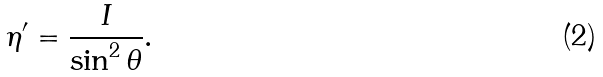<formula> <loc_0><loc_0><loc_500><loc_500>\eta ^ { \prime } = \frac { I } { \sin ^ { 2 } \theta } .</formula> 